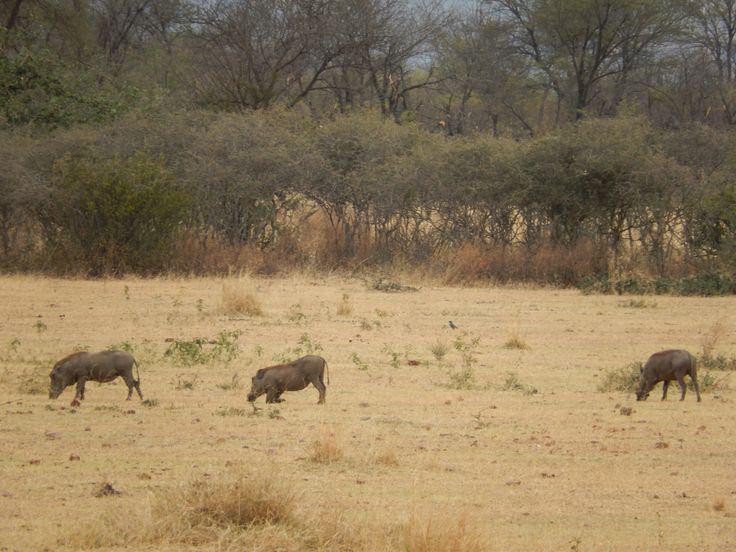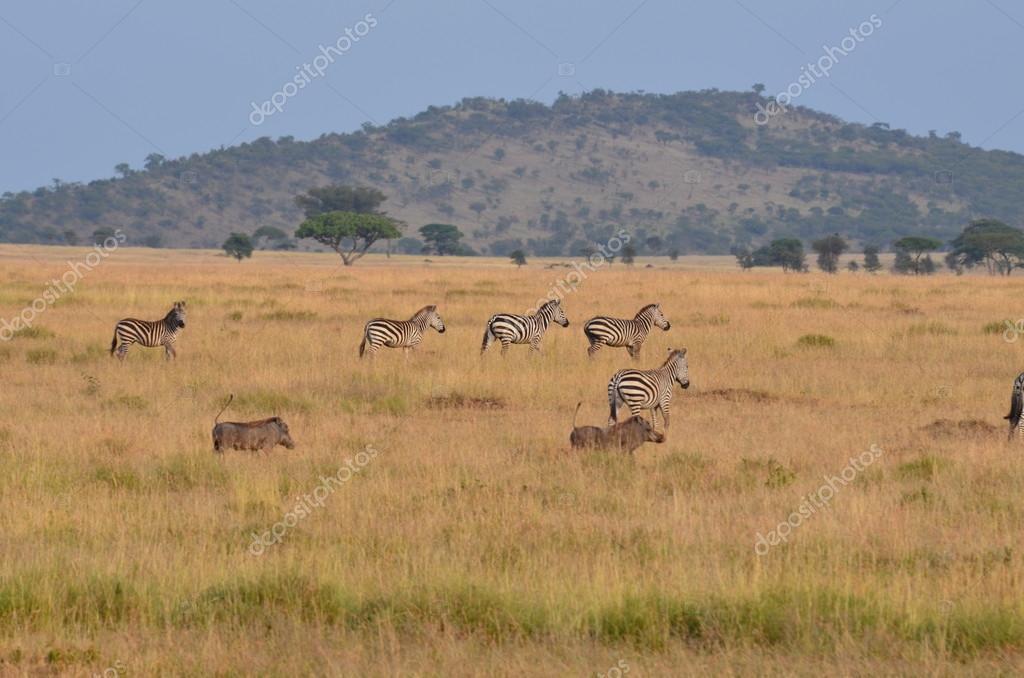The first image is the image on the left, the second image is the image on the right. Evaluate the accuracy of this statement regarding the images: "Multiple zebra are standing behind at least one warthog in an image.". Is it true? Answer yes or no. Yes. The first image is the image on the left, the second image is the image on the right. Analyze the images presented: Is the assertion "One of the images shows a group of warthogs with a group of zebras in the background." valid? Answer yes or no. Yes. 